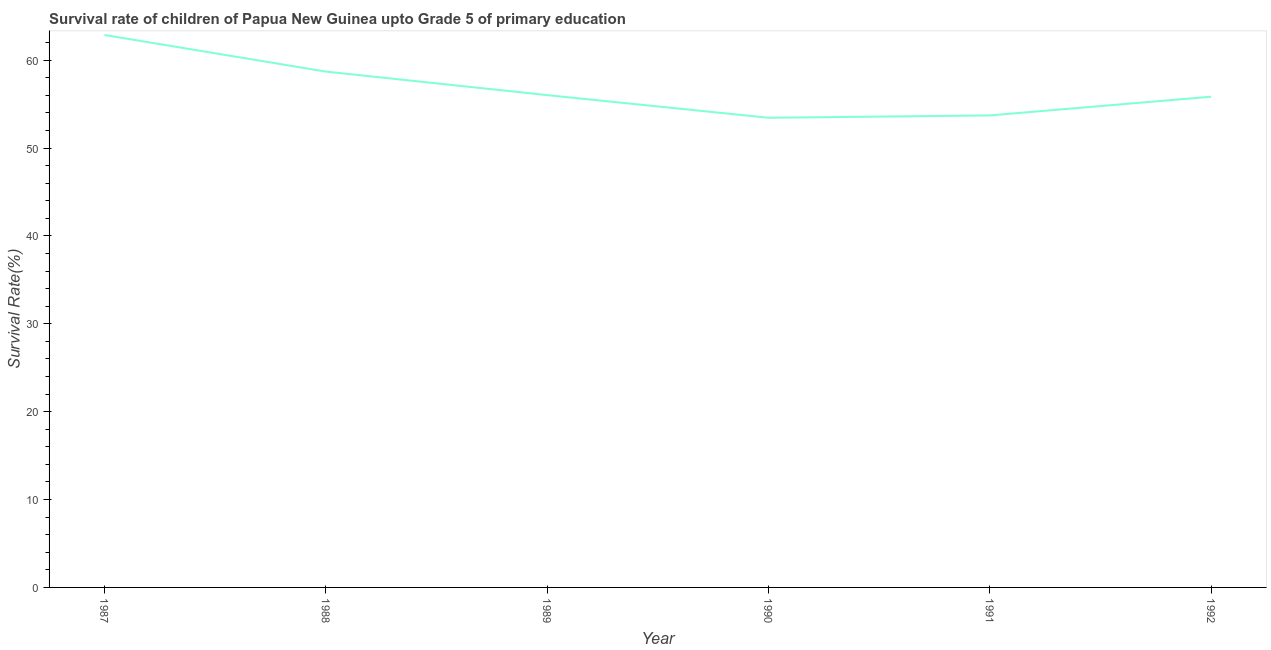What is the survival rate in 1990?
Keep it short and to the point. 53.46. Across all years, what is the maximum survival rate?
Make the answer very short. 62.88. Across all years, what is the minimum survival rate?
Your answer should be compact. 53.46. In which year was the survival rate minimum?
Your answer should be very brief. 1990. What is the sum of the survival rate?
Make the answer very short. 340.65. What is the difference between the survival rate in 1989 and 1991?
Ensure brevity in your answer.  2.31. What is the average survival rate per year?
Your answer should be compact. 56.78. What is the median survival rate?
Offer a terse response. 55.94. In how many years, is the survival rate greater than 28 %?
Ensure brevity in your answer.  6. Do a majority of the years between 1991 and 1992 (inclusive) have survival rate greater than 30 %?
Make the answer very short. Yes. What is the ratio of the survival rate in 1989 to that in 1991?
Provide a short and direct response. 1.04. Is the survival rate in 1987 less than that in 1991?
Provide a short and direct response. No. What is the difference between the highest and the second highest survival rate?
Provide a short and direct response. 4.17. Is the sum of the survival rate in 1988 and 1992 greater than the maximum survival rate across all years?
Provide a short and direct response. Yes. What is the difference between the highest and the lowest survival rate?
Your response must be concise. 9.42. How many lines are there?
Provide a succinct answer. 1. What is the difference between two consecutive major ticks on the Y-axis?
Offer a very short reply. 10. Are the values on the major ticks of Y-axis written in scientific E-notation?
Your answer should be very brief. No. What is the title of the graph?
Give a very brief answer. Survival rate of children of Papua New Guinea upto Grade 5 of primary education. What is the label or title of the Y-axis?
Your answer should be very brief. Survival Rate(%). What is the Survival Rate(%) of 1987?
Offer a terse response. 62.88. What is the Survival Rate(%) in 1988?
Your response must be concise. 58.71. What is the Survival Rate(%) in 1989?
Your answer should be compact. 56.03. What is the Survival Rate(%) in 1990?
Offer a terse response. 53.46. What is the Survival Rate(%) of 1991?
Provide a short and direct response. 53.72. What is the Survival Rate(%) of 1992?
Your answer should be compact. 55.85. What is the difference between the Survival Rate(%) in 1987 and 1988?
Make the answer very short. 4.17. What is the difference between the Survival Rate(%) in 1987 and 1989?
Provide a short and direct response. 6.85. What is the difference between the Survival Rate(%) in 1987 and 1990?
Make the answer very short. 9.42. What is the difference between the Survival Rate(%) in 1987 and 1991?
Give a very brief answer. 9.16. What is the difference between the Survival Rate(%) in 1987 and 1992?
Your answer should be very brief. 7.03. What is the difference between the Survival Rate(%) in 1988 and 1989?
Provide a short and direct response. 2.68. What is the difference between the Survival Rate(%) in 1988 and 1990?
Give a very brief answer. 5.26. What is the difference between the Survival Rate(%) in 1988 and 1991?
Keep it short and to the point. 4.99. What is the difference between the Survival Rate(%) in 1988 and 1992?
Make the answer very short. 2.86. What is the difference between the Survival Rate(%) in 1989 and 1990?
Provide a short and direct response. 2.58. What is the difference between the Survival Rate(%) in 1989 and 1991?
Your response must be concise. 2.31. What is the difference between the Survival Rate(%) in 1989 and 1992?
Keep it short and to the point. 0.18. What is the difference between the Survival Rate(%) in 1990 and 1991?
Offer a terse response. -0.27. What is the difference between the Survival Rate(%) in 1990 and 1992?
Give a very brief answer. -2.4. What is the difference between the Survival Rate(%) in 1991 and 1992?
Offer a very short reply. -2.13. What is the ratio of the Survival Rate(%) in 1987 to that in 1988?
Provide a short and direct response. 1.07. What is the ratio of the Survival Rate(%) in 1987 to that in 1989?
Provide a short and direct response. 1.12. What is the ratio of the Survival Rate(%) in 1987 to that in 1990?
Give a very brief answer. 1.18. What is the ratio of the Survival Rate(%) in 1987 to that in 1991?
Provide a succinct answer. 1.17. What is the ratio of the Survival Rate(%) in 1987 to that in 1992?
Offer a terse response. 1.13. What is the ratio of the Survival Rate(%) in 1988 to that in 1989?
Your response must be concise. 1.05. What is the ratio of the Survival Rate(%) in 1988 to that in 1990?
Keep it short and to the point. 1.1. What is the ratio of the Survival Rate(%) in 1988 to that in 1991?
Offer a very short reply. 1.09. What is the ratio of the Survival Rate(%) in 1988 to that in 1992?
Offer a very short reply. 1.05. What is the ratio of the Survival Rate(%) in 1989 to that in 1990?
Your answer should be very brief. 1.05. What is the ratio of the Survival Rate(%) in 1989 to that in 1991?
Make the answer very short. 1.04. What is the ratio of the Survival Rate(%) in 1990 to that in 1991?
Give a very brief answer. 0.99. 